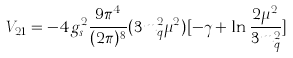<formula> <loc_0><loc_0><loc_500><loc_500>V _ { 2 1 } = - 4 g _ { s } ^ { 2 } \frac { 9 \pi ^ { 4 } } { ( 2 \pi ) ^ { 8 } } ( 3 m _ { q } ^ { 2 } \mu ^ { 2 } ) [ - \gamma + \ln \frac { 2 \mu ^ { 2 } } { 3 m _ { q } ^ { 2 } } ]</formula> 